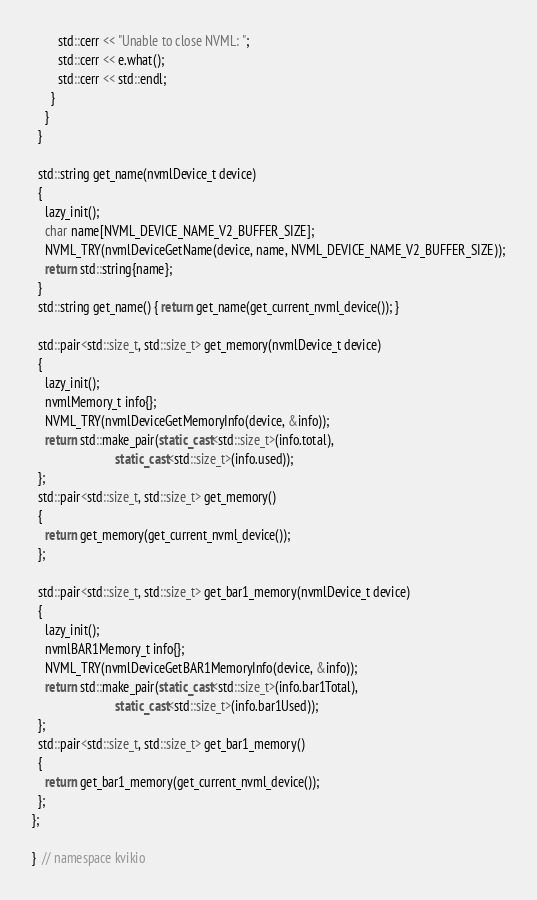<code> <loc_0><loc_0><loc_500><loc_500><_C++_>        std::cerr << "Unable to close NVML: ";
        std::cerr << e.what();
        std::cerr << std::endl;
      }
    }
  }

  std::string get_name(nvmlDevice_t device)
  {
    lazy_init();
    char name[NVML_DEVICE_NAME_V2_BUFFER_SIZE];
    NVML_TRY(nvmlDeviceGetName(device, name, NVML_DEVICE_NAME_V2_BUFFER_SIZE));
    return std::string{name};
  }
  std::string get_name() { return get_name(get_current_nvml_device()); }

  std::pair<std::size_t, std::size_t> get_memory(nvmlDevice_t device)
  {
    lazy_init();
    nvmlMemory_t info{};
    NVML_TRY(nvmlDeviceGetMemoryInfo(device, &info));
    return std::make_pair(static_cast<std::size_t>(info.total),
                          static_cast<std::size_t>(info.used));
  };
  std::pair<std::size_t, std::size_t> get_memory()
  {
    return get_memory(get_current_nvml_device());
  };

  std::pair<std::size_t, std::size_t> get_bar1_memory(nvmlDevice_t device)
  {
    lazy_init();
    nvmlBAR1Memory_t info{};
    NVML_TRY(nvmlDeviceGetBAR1MemoryInfo(device, &info));
    return std::make_pair(static_cast<std::size_t>(info.bar1Total),
                          static_cast<std::size_t>(info.bar1Used));
  };
  std::pair<std::size_t, std::size_t> get_bar1_memory()
  {
    return get_bar1_memory(get_current_nvml_device());
  };
};

}  // namespace kvikio
</code> 